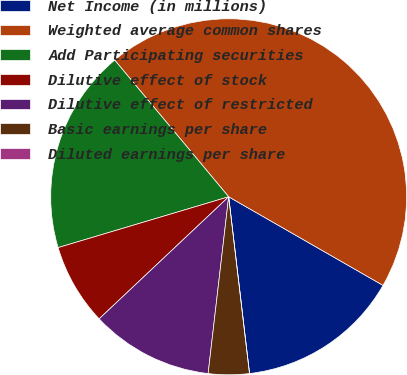Convert chart to OTSL. <chart><loc_0><loc_0><loc_500><loc_500><pie_chart><fcel>Net Income (in millions)<fcel>Weighted average common shares<fcel>Add Participating securities<fcel>Dilutive effect of stock<fcel>Dilutive effect of restricted<fcel>Basic earnings per share<fcel>Diluted earnings per share<nl><fcel>14.84%<fcel>44.36%<fcel>18.55%<fcel>7.42%<fcel>11.13%<fcel>3.71%<fcel>0.0%<nl></chart> 